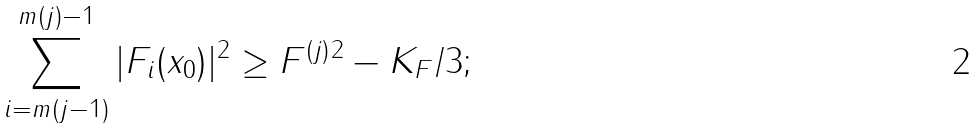<formula> <loc_0><loc_0><loc_500><loc_500>\sum _ { i = m ( j - 1 ) } ^ { m ( j ) - 1 } | F _ { i } ( x _ { 0 } ) | ^ { 2 } \geq \| F ^ { ( j ) } \| ^ { 2 } - K _ { F } / 3 ;</formula> 